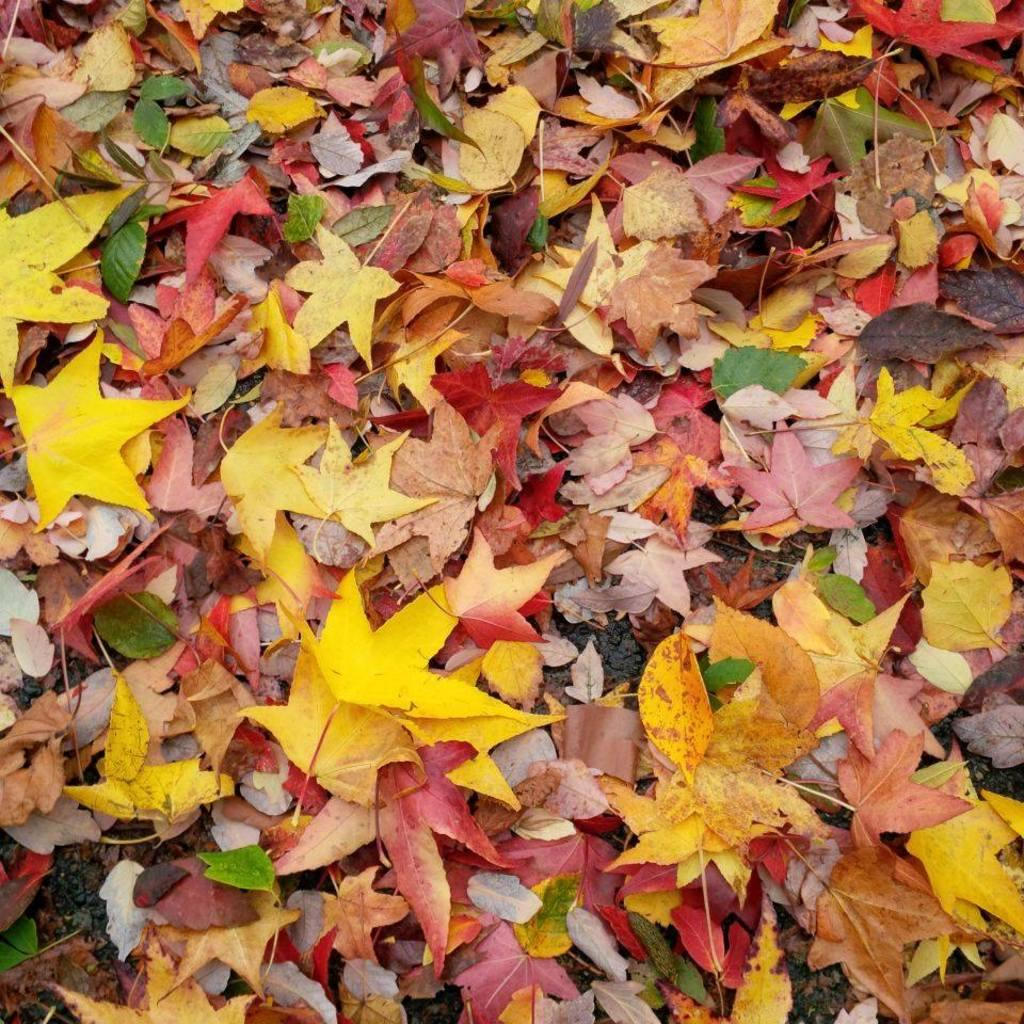What type of vegetation can be seen on the ground in the image? There are different color leaves on the ground. What might be the cause of the leaves being on the ground? The leaves may have fallen from trees due to seasonal changes or other factors. What can be inferred about the season or weather based on the leaves on the ground? The presence of fallen leaves may suggest that it is autumn or that there has been a recent windy or stormy weather event. What type of religious symbol can be seen on the wall in the image? There is no wall or religious symbol present in the image; it only features different color leaves on the ground. 